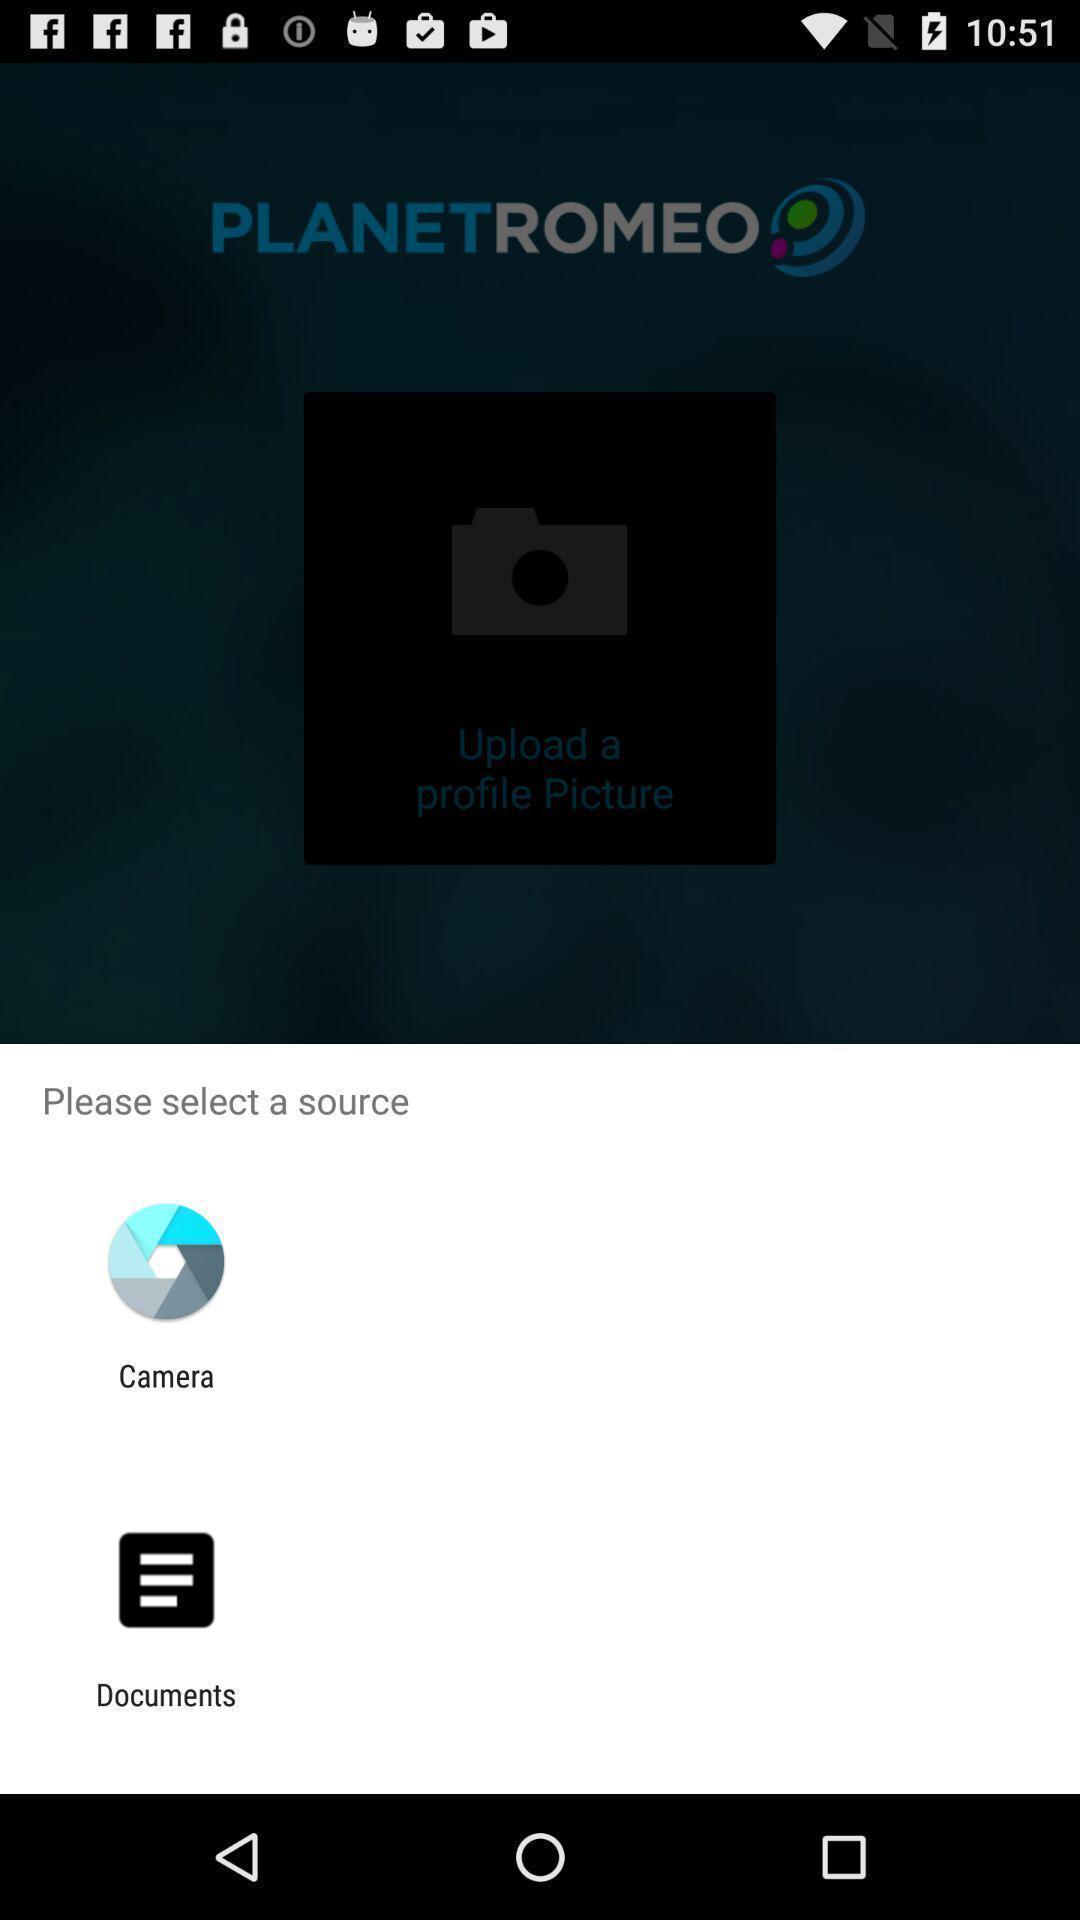Summarize the main components in this picture. Pop-up is showing two app sources for uploading. 